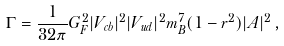<formula> <loc_0><loc_0><loc_500><loc_500>\Gamma = \frac { 1 } { 3 2 \pi } G _ { F } ^ { 2 } | V _ { c b } | ^ { 2 } | V _ { u d } | ^ { 2 } m _ { B } ^ { 7 } ( 1 - r ^ { 2 } ) | A | ^ { 2 } \, ,</formula> 